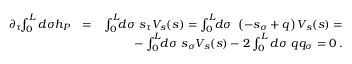<formula> <loc_0><loc_0><loc_500><loc_500>\begin{array} { r l r } { \partial _ { \tau } \, \int _ { 0 } ^ { L } d \sigma h _ { P } } & { = } & { \int _ { 0 } ^ { L } \, d \sigma s _ { \tau } V _ { s } ( s ) = \int _ { 0 } ^ { L } \, d \sigma \left ( - s _ { \sigma } + q \right ) V _ { s } ( s ) = } \\ & { - \int _ { 0 } ^ { L } \, d \sigma s _ { \sigma } V _ { s } ( s ) - 2 \int _ { 0 } ^ { L } d \sigma q q _ { \sigma } = 0 \, . } \end{array}</formula> 